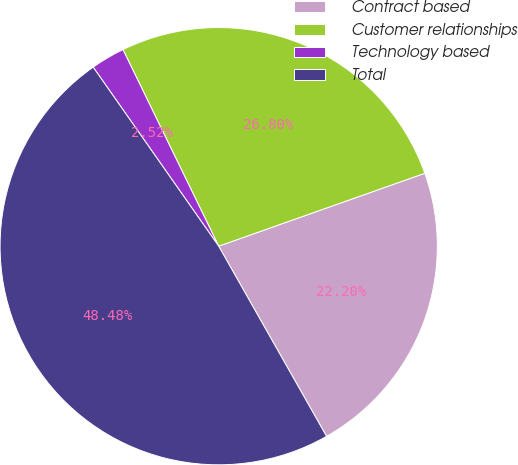Convert chart. <chart><loc_0><loc_0><loc_500><loc_500><pie_chart><fcel>Contract based<fcel>Customer relationships<fcel>Technology based<fcel>Total<nl><fcel>22.2%<fcel>26.8%<fcel>2.52%<fcel>48.48%<nl></chart> 